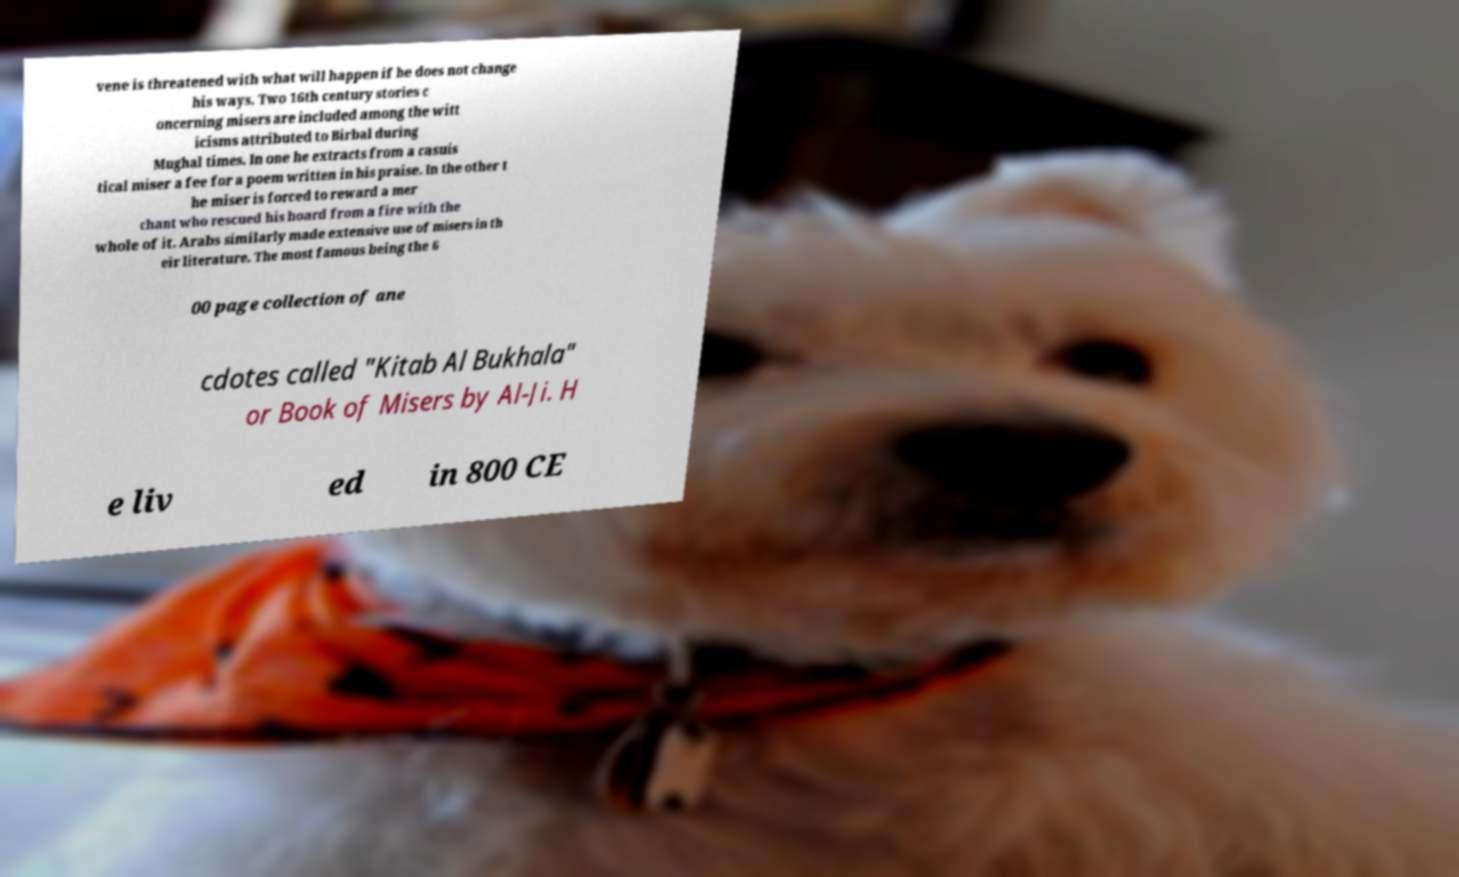Please read and relay the text visible in this image. What does it say? vene is threatened with what will happen if he does not change his ways. Two 16th century stories c oncerning misers are included among the witt icisms attributed to Birbal during Mughal times. In one he extracts from a casuis tical miser a fee for a poem written in his praise. In the other t he miser is forced to reward a mer chant who rescued his hoard from a fire with the whole of it. Arabs similarly made extensive use of misers in th eir literature. The most famous being the 6 00 page collection of ane cdotes called "Kitab Al Bukhala" or Book of Misers by Al-Ji. H e liv ed in 800 CE 